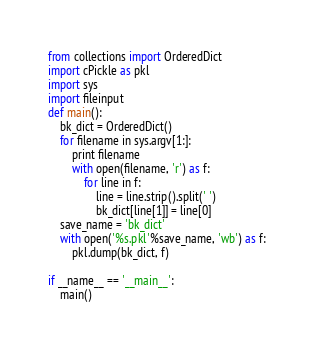Convert code to text. <code><loc_0><loc_0><loc_500><loc_500><_Python_>from collections import OrderedDict 
import cPickle as pkl 
import sys
import fileinput
def main():
    bk_dict = OrderedDict()
    for filename in sys.argv[1:]:
        print filename
        with open(filename, 'r') as f:
            for line in f:
                line = line.strip().split(' ')
                bk_dict[line[1]] = line[0]
    save_name = 'bk_dict'
    with open('%s.pkl'%save_name, 'wb') as f:
        pkl.dump(bk_dict, f)

if __name__ == '__main__':
    main()
</code> 